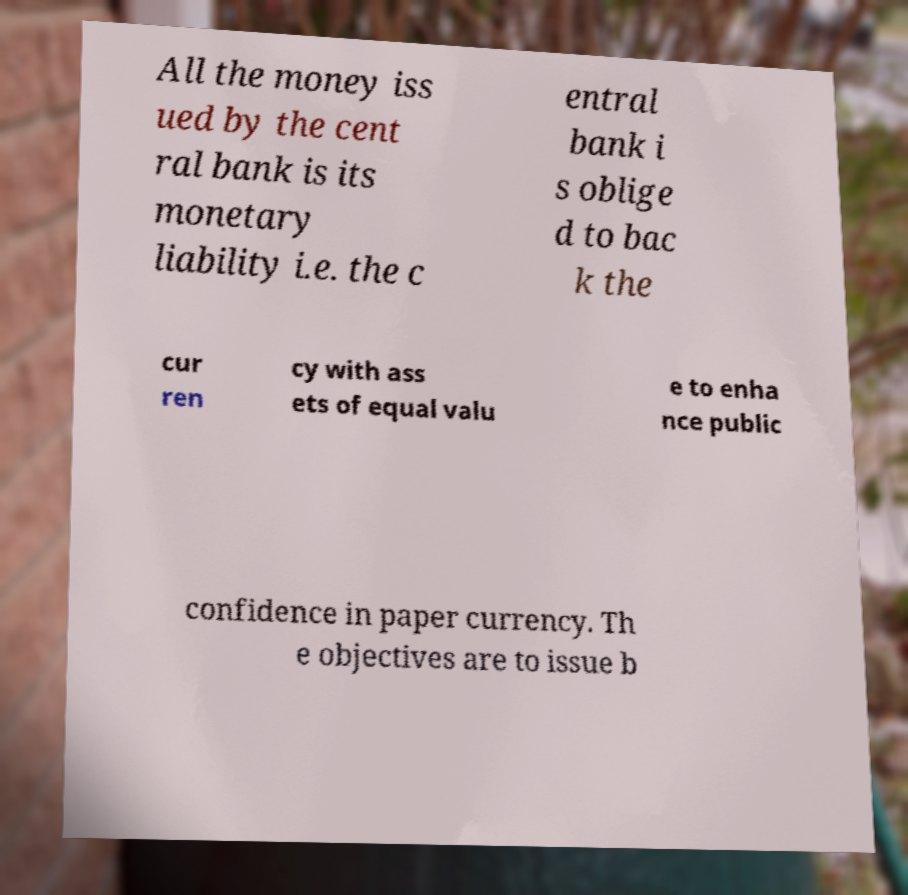For documentation purposes, I need the text within this image transcribed. Could you provide that? All the money iss ued by the cent ral bank is its monetary liability i.e. the c entral bank i s oblige d to bac k the cur ren cy with ass ets of equal valu e to enha nce public confidence in paper currency. Th e objectives are to issue b 